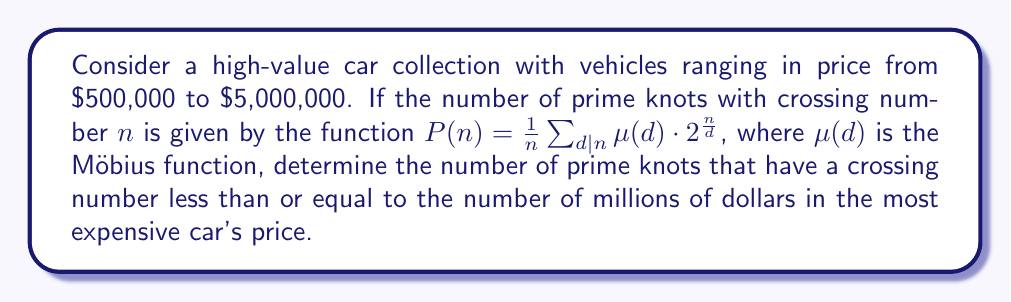Can you solve this math problem? 1) First, we need to identify the crossing number limit:
   The most expensive car is $5,000,000, which is 5 million dollars.
   So, we'll calculate prime knots for crossing numbers up to 5.

2) We'll use the given function: $P(n) = \frac{1}{n} \sum_{d|n} \mu(d) \cdot 2^{\frac{n}{d}}$

3) Calculate for each $n$ from 1 to 5:

   For $n = 1$:
   $P(1) = \frac{1}{1} [\mu(1) \cdot 2^1] = 1 \cdot 2 = 2$

   For $n = 2$:
   $P(2) = \frac{1}{2} [\mu(1) \cdot 2^2 + \mu(2) \cdot 2^1] = \frac{1}{2} [1 \cdot 4 + (-1) \cdot 2] = 1$

   For $n = 3$:
   $P(3) = \frac{1}{3} [\mu(1) \cdot 2^3 + \mu(3) \cdot 2^1] = \frac{1}{3} [1 \cdot 8 + (-1) \cdot 2] = 2$

   For $n = 4$:
   $P(4) = \frac{1}{4} [\mu(1) \cdot 2^4 + \mu(2) \cdot 2^2 + \mu(4) \cdot 2^1] = \frac{1}{4} [1 \cdot 16 + (-1) \cdot 4 + 0 \cdot 2] = 3$

   For $n = 5$:
   $P(5) = \frac{1}{5} [\mu(1) \cdot 2^5 + \mu(5) \cdot 2^1] = \frac{1}{5} [1 \cdot 32 + (-1) \cdot 2] = 6$

4) Sum up all the prime knots:
   $2 + 1 + 2 + 3 + 6 = 14$

Therefore, there are 14 prime knots with crossing numbers less than or equal to 5.
Answer: 14 